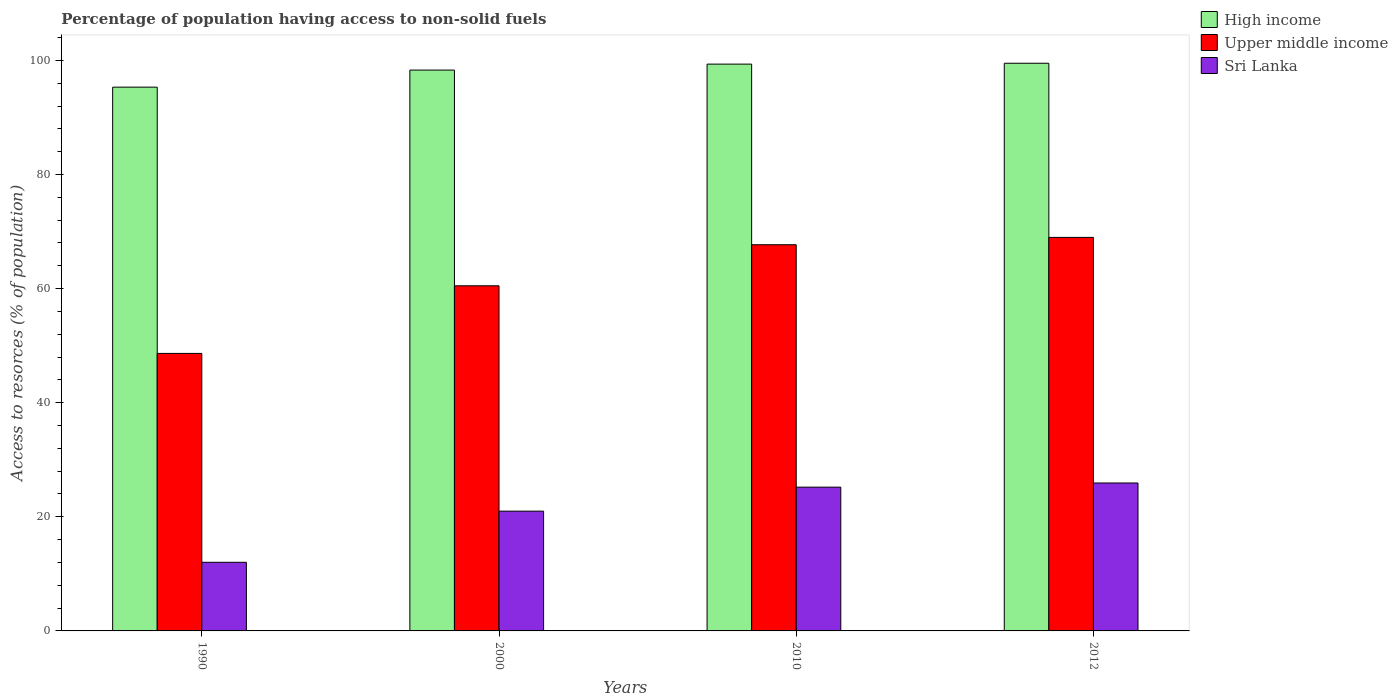How many different coloured bars are there?
Keep it short and to the point. 3. How many groups of bars are there?
Your response must be concise. 4. Are the number of bars on each tick of the X-axis equal?
Provide a short and direct response. Yes. How many bars are there on the 2nd tick from the left?
Your answer should be compact. 3. What is the percentage of population having access to non-solid fuels in Sri Lanka in 2012?
Provide a succinct answer. 25.93. Across all years, what is the maximum percentage of population having access to non-solid fuels in High income?
Provide a succinct answer. 99.49. Across all years, what is the minimum percentage of population having access to non-solid fuels in Sri Lanka?
Offer a terse response. 12.03. In which year was the percentage of population having access to non-solid fuels in Upper middle income maximum?
Keep it short and to the point. 2012. In which year was the percentage of population having access to non-solid fuels in Sri Lanka minimum?
Make the answer very short. 1990. What is the total percentage of population having access to non-solid fuels in High income in the graph?
Offer a very short reply. 392.44. What is the difference between the percentage of population having access to non-solid fuels in Upper middle income in 2010 and that in 2012?
Give a very brief answer. -1.29. What is the difference between the percentage of population having access to non-solid fuels in Sri Lanka in 2010 and the percentage of population having access to non-solid fuels in Upper middle income in 2012?
Keep it short and to the point. -43.77. What is the average percentage of population having access to non-solid fuels in Upper middle income per year?
Keep it short and to the point. 61.44. In the year 1990, what is the difference between the percentage of population having access to non-solid fuels in High income and percentage of population having access to non-solid fuels in Upper middle income?
Make the answer very short. 46.67. In how many years, is the percentage of population having access to non-solid fuels in High income greater than 28 %?
Provide a short and direct response. 4. What is the ratio of the percentage of population having access to non-solid fuels in Sri Lanka in 2010 to that in 2012?
Make the answer very short. 0.97. Is the percentage of population having access to non-solid fuels in Sri Lanka in 1990 less than that in 2012?
Give a very brief answer. Yes. Is the difference between the percentage of population having access to non-solid fuels in High income in 2010 and 2012 greater than the difference between the percentage of population having access to non-solid fuels in Upper middle income in 2010 and 2012?
Your response must be concise. Yes. What is the difference between the highest and the second highest percentage of population having access to non-solid fuels in Upper middle income?
Provide a short and direct response. 1.29. What is the difference between the highest and the lowest percentage of population having access to non-solid fuels in Sri Lanka?
Give a very brief answer. 13.9. In how many years, is the percentage of population having access to non-solid fuels in Upper middle income greater than the average percentage of population having access to non-solid fuels in Upper middle income taken over all years?
Offer a very short reply. 2. What does the 3rd bar from the left in 2000 represents?
Provide a short and direct response. Sri Lanka. Is it the case that in every year, the sum of the percentage of population having access to non-solid fuels in Sri Lanka and percentage of population having access to non-solid fuels in High income is greater than the percentage of population having access to non-solid fuels in Upper middle income?
Your response must be concise. Yes. How many bars are there?
Keep it short and to the point. 12. Are all the bars in the graph horizontal?
Offer a very short reply. No. How many years are there in the graph?
Your answer should be very brief. 4. What is the difference between two consecutive major ticks on the Y-axis?
Your answer should be compact. 20. Does the graph contain grids?
Your answer should be very brief. No. Where does the legend appear in the graph?
Your response must be concise. Top right. How many legend labels are there?
Make the answer very short. 3. How are the legend labels stacked?
Your answer should be very brief. Vertical. What is the title of the graph?
Give a very brief answer. Percentage of population having access to non-solid fuels. What is the label or title of the Y-axis?
Ensure brevity in your answer.  Access to resorces (% of population). What is the Access to resorces (% of population) of High income in 1990?
Your answer should be compact. 95.31. What is the Access to resorces (% of population) in Upper middle income in 1990?
Give a very brief answer. 48.64. What is the Access to resorces (% of population) of Sri Lanka in 1990?
Provide a short and direct response. 12.03. What is the Access to resorces (% of population) in High income in 2000?
Make the answer very short. 98.3. What is the Access to resorces (% of population) of Upper middle income in 2000?
Your answer should be compact. 60.49. What is the Access to resorces (% of population) in Sri Lanka in 2000?
Your answer should be very brief. 20.99. What is the Access to resorces (% of population) in High income in 2010?
Your answer should be compact. 99.34. What is the Access to resorces (% of population) of Upper middle income in 2010?
Give a very brief answer. 67.69. What is the Access to resorces (% of population) in Sri Lanka in 2010?
Provide a short and direct response. 25.2. What is the Access to resorces (% of population) in High income in 2012?
Offer a very short reply. 99.49. What is the Access to resorces (% of population) in Upper middle income in 2012?
Your answer should be very brief. 68.97. What is the Access to resorces (% of population) in Sri Lanka in 2012?
Your answer should be compact. 25.93. Across all years, what is the maximum Access to resorces (% of population) in High income?
Your answer should be very brief. 99.49. Across all years, what is the maximum Access to resorces (% of population) in Upper middle income?
Keep it short and to the point. 68.97. Across all years, what is the maximum Access to resorces (% of population) of Sri Lanka?
Your response must be concise. 25.93. Across all years, what is the minimum Access to resorces (% of population) of High income?
Offer a very short reply. 95.31. Across all years, what is the minimum Access to resorces (% of population) in Upper middle income?
Provide a short and direct response. 48.64. Across all years, what is the minimum Access to resorces (% of population) in Sri Lanka?
Offer a terse response. 12.03. What is the total Access to resorces (% of population) of High income in the graph?
Offer a terse response. 392.44. What is the total Access to resorces (% of population) in Upper middle income in the graph?
Ensure brevity in your answer.  245.78. What is the total Access to resorces (% of population) in Sri Lanka in the graph?
Offer a terse response. 84.15. What is the difference between the Access to resorces (% of population) in High income in 1990 and that in 2000?
Your answer should be compact. -2.99. What is the difference between the Access to resorces (% of population) of Upper middle income in 1990 and that in 2000?
Your answer should be compact. -11.85. What is the difference between the Access to resorces (% of population) of Sri Lanka in 1990 and that in 2000?
Give a very brief answer. -8.96. What is the difference between the Access to resorces (% of population) of High income in 1990 and that in 2010?
Ensure brevity in your answer.  -4.04. What is the difference between the Access to resorces (% of population) in Upper middle income in 1990 and that in 2010?
Your answer should be very brief. -19.05. What is the difference between the Access to resorces (% of population) in Sri Lanka in 1990 and that in 2010?
Your response must be concise. -13.17. What is the difference between the Access to resorces (% of population) in High income in 1990 and that in 2012?
Offer a very short reply. -4.19. What is the difference between the Access to resorces (% of population) of Upper middle income in 1990 and that in 2012?
Offer a terse response. -20.34. What is the difference between the Access to resorces (% of population) of Sri Lanka in 1990 and that in 2012?
Ensure brevity in your answer.  -13.9. What is the difference between the Access to resorces (% of population) of High income in 2000 and that in 2010?
Offer a terse response. -1.04. What is the difference between the Access to resorces (% of population) in Upper middle income in 2000 and that in 2010?
Your answer should be very brief. -7.2. What is the difference between the Access to resorces (% of population) in Sri Lanka in 2000 and that in 2010?
Your answer should be very brief. -4.21. What is the difference between the Access to resorces (% of population) in High income in 2000 and that in 2012?
Your answer should be very brief. -1.2. What is the difference between the Access to resorces (% of population) of Upper middle income in 2000 and that in 2012?
Make the answer very short. -8.49. What is the difference between the Access to resorces (% of population) in Sri Lanka in 2000 and that in 2012?
Provide a short and direct response. -4.94. What is the difference between the Access to resorces (% of population) in High income in 2010 and that in 2012?
Your answer should be compact. -0.15. What is the difference between the Access to resorces (% of population) of Upper middle income in 2010 and that in 2012?
Your answer should be compact. -1.29. What is the difference between the Access to resorces (% of population) of Sri Lanka in 2010 and that in 2012?
Your answer should be compact. -0.73. What is the difference between the Access to resorces (% of population) in High income in 1990 and the Access to resorces (% of population) in Upper middle income in 2000?
Provide a short and direct response. 34.82. What is the difference between the Access to resorces (% of population) in High income in 1990 and the Access to resorces (% of population) in Sri Lanka in 2000?
Provide a short and direct response. 74.32. What is the difference between the Access to resorces (% of population) in Upper middle income in 1990 and the Access to resorces (% of population) in Sri Lanka in 2000?
Offer a terse response. 27.65. What is the difference between the Access to resorces (% of population) in High income in 1990 and the Access to resorces (% of population) in Upper middle income in 2010?
Offer a terse response. 27.62. What is the difference between the Access to resorces (% of population) in High income in 1990 and the Access to resorces (% of population) in Sri Lanka in 2010?
Your answer should be very brief. 70.11. What is the difference between the Access to resorces (% of population) in Upper middle income in 1990 and the Access to resorces (% of population) in Sri Lanka in 2010?
Make the answer very short. 23.44. What is the difference between the Access to resorces (% of population) in High income in 1990 and the Access to resorces (% of population) in Upper middle income in 2012?
Provide a succinct answer. 26.33. What is the difference between the Access to resorces (% of population) in High income in 1990 and the Access to resorces (% of population) in Sri Lanka in 2012?
Offer a very short reply. 69.38. What is the difference between the Access to resorces (% of population) in Upper middle income in 1990 and the Access to resorces (% of population) in Sri Lanka in 2012?
Keep it short and to the point. 22.71. What is the difference between the Access to resorces (% of population) of High income in 2000 and the Access to resorces (% of population) of Upper middle income in 2010?
Your answer should be very brief. 30.61. What is the difference between the Access to resorces (% of population) of High income in 2000 and the Access to resorces (% of population) of Sri Lanka in 2010?
Your response must be concise. 73.1. What is the difference between the Access to resorces (% of population) of Upper middle income in 2000 and the Access to resorces (% of population) of Sri Lanka in 2010?
Provide a short and direct response. 35.29. What is the difference between the Access to resorces (% of population) of High income in 2000 and the Access to resorces (% of population) of Upper middle income in 2012?
Offer a very short reply. 29.33. What is the difference between the Access to resorces (% of population) in High income in 2000 and the Access to resorces (% of population) in Sri Lanka in 2012?
Your answer should be compact. 72.37. What is the difference between the Access to resorces (% of population) of Upper middle income in 2000 and the Access to resorces (% of population) of Sri Lanka in 2012?
Provide a short and direct response. 34.56. What is the difference between the Access to resorces (% of population) in High income in 2010 and the Access to resorces (% of population) in Upper middle income in 2012?
Keep it short and to the point. 30.37. What is the difference between the Access to resorces (% of population) in High income in 2010 and the Access to resorces (% of population) in Sri Lanka in 2012?
Provide a short and direct response. 73.41. What is the difference between the Access to resorces (% of population) in Upper middle income in 2010 and the Access to resorces (% of population) in Sri Lanka in 2012?
Offer a terse response. 41.76. What is the average Access to resorces (% of population) of High income per year?
Your answer should be very brief. 98.11. What is the average Access to resorces (% of population) in Upper middle income per year?
Your response must be concise. 61.44. What is the average Access to resorces (% of population) of Sri Lanka per year?
Your response must be concise. 21.04. In the year 1990, what is the difference between the Access to resorces (% of population) of High income and Access to resorces (% of population) of Upper middle income?
Offer a very short reply. 46.67. In the year 1990, what is the difference between the Access to resorces (% of population) in High income and Access to resorces (% of population) in Sri Lanka?
Provide a succinct answer. 83.28. In the year 1990, what is the difference between the Access to resorces (% of population) of Upper middle income and Access to resorces (% of population) of Sri Lanka?
Your answer should be compact. 36.61. In the year 2000, what is the difference between the Access to resorces (% of population) in High income and Access to resorces (% of population) in Upper middle income?
Your answer should be compact. 37.81. In the year 2000, what is the difference between the Access to resorces (% of population) in High income and Access to resorces (% of population) in Sri Lanka?
Give a very brief answer. 77.31. In the year 2000, what is the difference between the Access to resorces (% of population) in Upper middle income and Access to resorces (% of population) in Sri Lanka?
Ensure brevity in your answer.  39.5. In the year 2010, what is the difference between the Access to resorces (% of population) of High income and Access to resorces (% of population) of Upper middle income?
Provide a short and direct response. 31.66. In the year 2010, what is the difference between the Access to resorces (% of population) in High income and Access to resorces (% of population) in Sri Lanka?
Your answer should be very brief. 74.14. In the year 2010, what is the difference between the Access to resorces (% of population) of Upper middle income and Access to resorces (% of population) of Sri Lanka?
Provide a short and direct response. 42.49. In the year 2012, what is the difference between the Access to resorces (% of population) in High income and Access to resorces (% of population) in Upper middle income?
Ensure brevity in your answer.  30.52. In the year 2012, what is the difference between the Access to resorces (% of population) in High income and Access to resorces (% of population) in Sri Lanka?
Offer a terse response. 73.56. In the year 2012, what is the difference between the Access to resorces (% of population) of Upper middle income and Access to resorces (% of population) of Sri Lanka?
Your answer should be compact. 43.04. What is the ratio of the Access to resorces (% of population) of High income in 1990 to that in 2000?
Offer a very short reply. 0.97. What is the ratio of the Access to resorces (% of population) in Upper middle income in 1990 to that in 2000?
Provide a short and direct response. 0.8. What is the ratio of the Access to resorces (% of population) in Sri Lanka in 1990 to that in 2000?
Your response must be concise. 0.57. What is the ratio of the Access to resorces (% of population) in High income in 1990 to that in 2010?
Your response must be concise. 0.96. What is the ratio of the Access to resorces (% of population) in Upper middle income in 1990 to that in 2010?
Offer a terse response. 0.72. What is the ratio of the Access to resorces (% of population) of Sri Lanka in 1990 to that in 2010?
Provide a short and direct response. 0.48. What is the ratio of the Access to resorces (% of population) of High income in 1990 to that in 2012?
Give a very brief answer. 0.96. What is the ratio of the Access to resorces (% of population) in Upper middle income in 1990 to that in 2012?
Make the answer very short. 0.71. What is the ratio of the Access to resorces (% of population) in Sri Lanka in 1990 to that in 2012?
Offer a very short reply. 0.46. What is the ratio of the Access to resorces (% of population) in Upper middle income in 2000 to that in 2010?
Make the answer very short. 0.89. What is the ratio of the Access to resorces (% of population) of Sri Lanka in 2000 to that in 2010?
Provide a short and direct response. 0.83. What is the ratio of the Access to resorces (% of population) of Upper middle income in 2000 to that in 2012?
Offer a very short reply. 0.88. What is the ratio of the Access to resorces (% of population) in Sri Lanka in 2000 to that in 2012?
Provide a succinct answer. 0.81. What is the ratio of the Access to resorces (% of population) in Upper middle income in 2010 to that in 2012?
Give a very brief answer. 0.98. What is the ratio of the Access to resorces (% of population) of Sri Lanka in 2010 to that in 2012?
Provide a short and direct response. 0.97. What is the difference between the highest and the second highest Access to resorces (% of population) of High income?
Provide a short and direct response. 0.15. What is the difference between the highest and the second highest Access to resorces (% of population) in Upper middle income?
Provide a short and direct response. 1.29. What is the difference between the highest and the second highest Access to resorces (% of population) of Sri Lanka?
Provide a short and direct response. 0.73. What is the difference between the highest and the lowest Access to resorces (% of population) in High income?
Offer a terse response. 4.19. What is the difference between the highest and the lowest Access to resorces (% of population) in Upper middle income?
Give a very brief answer. 20.34. What is the difference between the highest and the lowest Access to resorces (% of population) in Sri Lanka?
Provide a succinct answer. 13.9. 